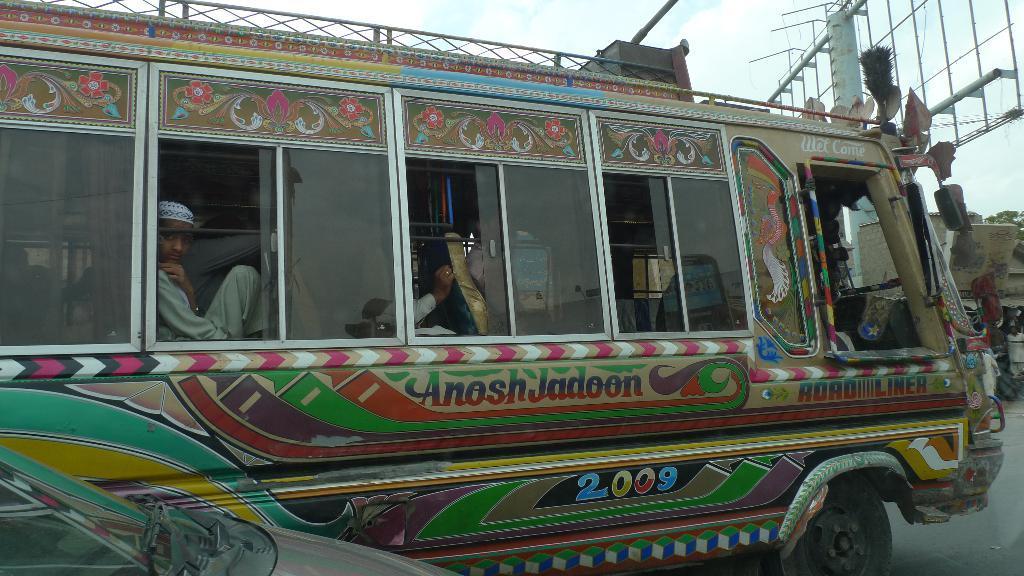Describe this image in one or two sentences. In the picture we can see a bus which is designed with paintings and with a glass windows and from it we can see some people are sitting in the seats and in front of the bus we can see a pole with a hoarding stand and near it we can see a house and behind it we can see a sky with clouds. 